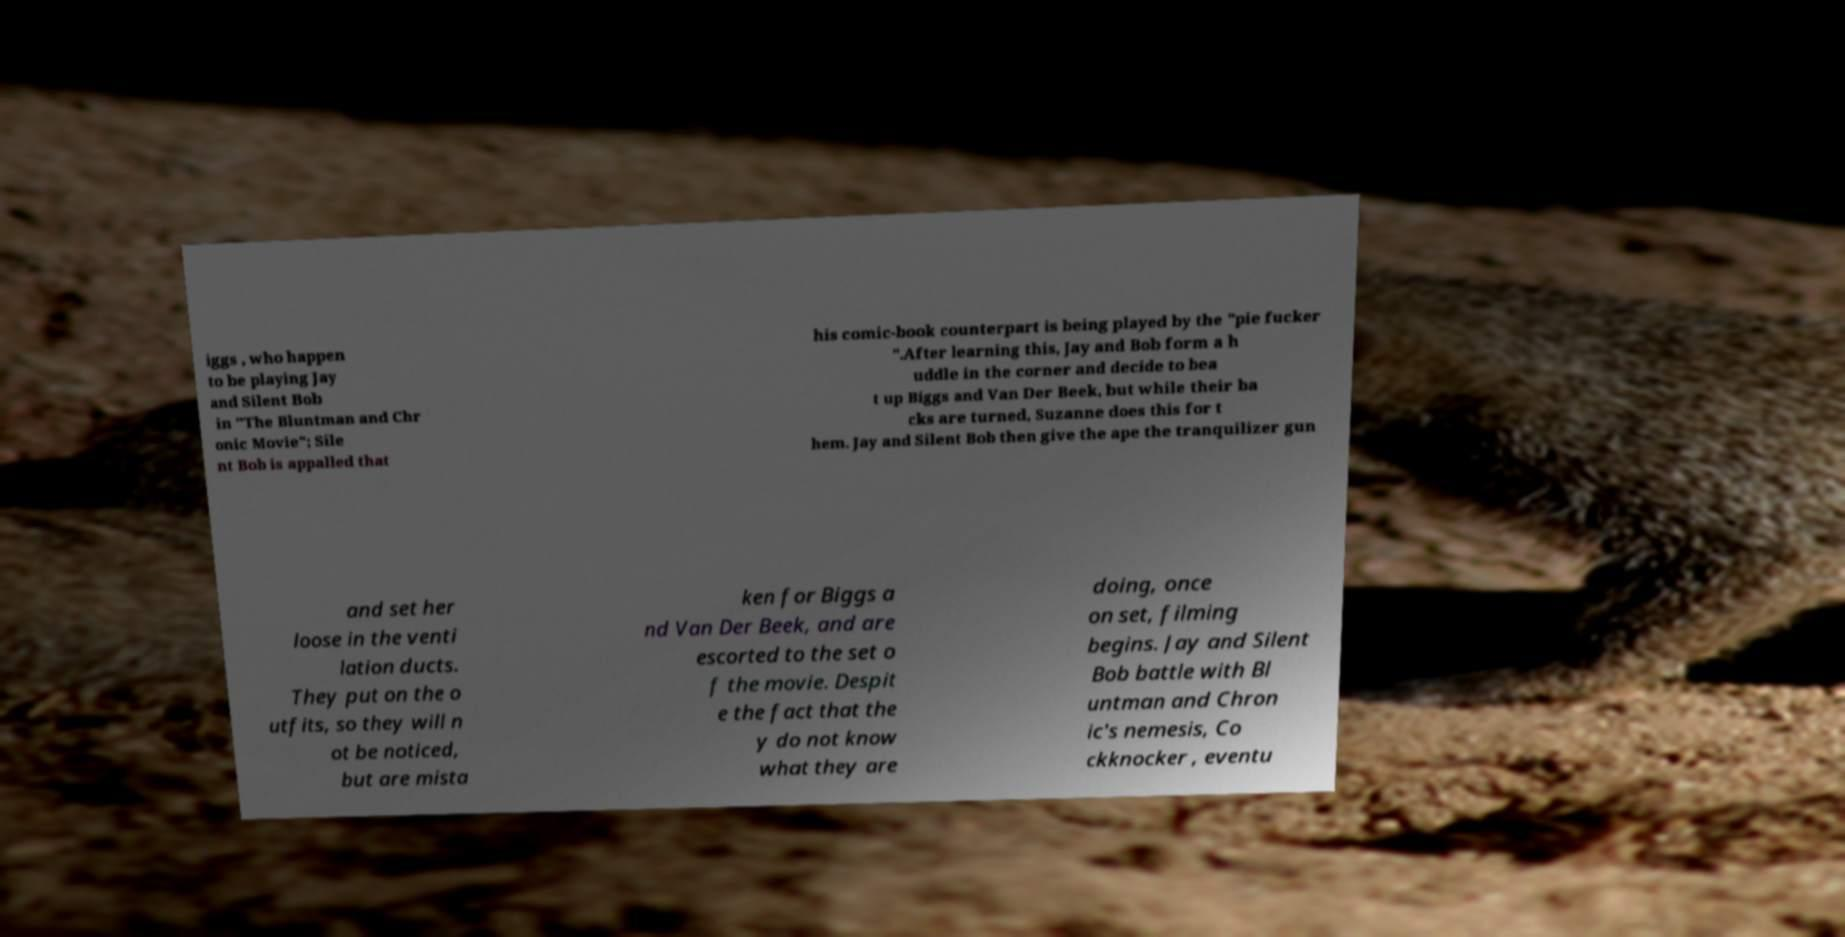Can you accurately transcribe the text from the provided image for me? iggs , who happen to be playing Jay and Silent Bob in "The Bluntman and Chr onic Movie"; Sile nt Bob is appalled that his comic-book counterpart is being played by the "pie fucker ".After learning this, Jay and Bob form a h uddle in the corner and decide to bea t up Biggs and Van Der Beek, but while their ba cks are turned, Suzanne does this for t hem. Jay and Silent Bob then give the ape the tranquilizer gun and set her loose in the venti lation ducts. They put on the o utfits, so they will n ot be noticed, but are mista ken for Biggs a nd Van Der Beek, and are escorted to the set o f the movie. Despit e the fact that the y do not know what they are doing, once on set, filming begins. Jay and Silent Bob battle with Bl untman and Chron ic's nemesis, Co ckknocker , eventu 